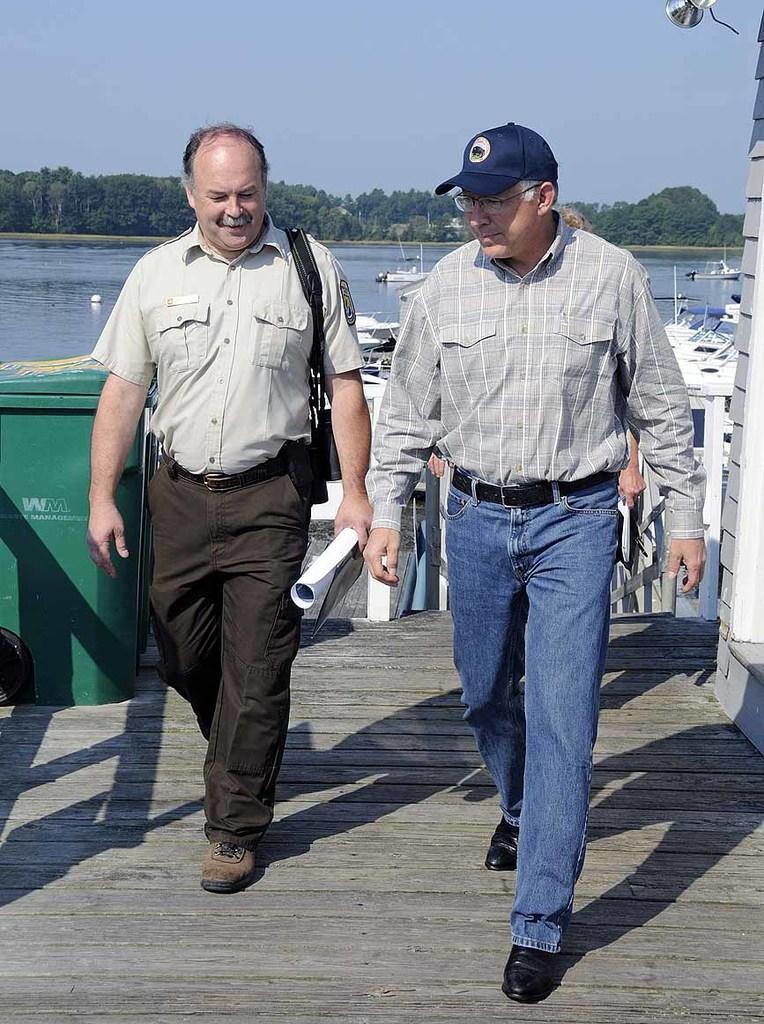How would you summarize this image in a sentence or two? Here in this picture we can see two men walking over a place and both of them are talking to each other and smiling and the man on the right side is wearing spectacles and cap and behind them we can see boats present in the water, as we can see water present all over there and on the left side we can see dustbin present and in the far we can see plants and trees covered over there and we can see the sky is cloudy. 